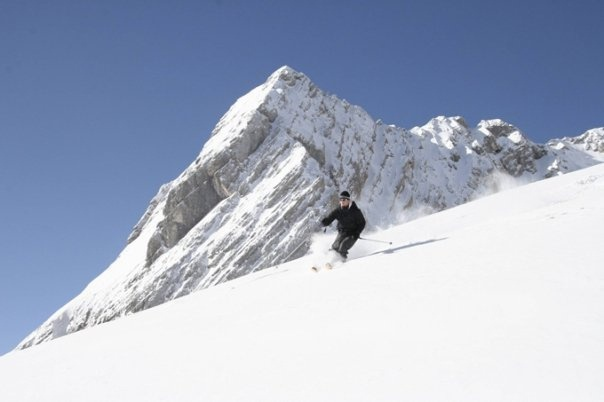Describe the objects in this image and their specific colors. I can see people in gray, black, and darkgray tones and skis in gray, lightgray, and darkgray tones in this image. 